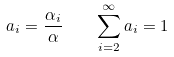Convert formula to latex. <formula><loc_0><loc_0><loc_500><loc_500>a _ { i } = \frac { \alpha _ { i } } { \alpha } \quad \sum _ { i = 2 } ^ { \infty } a _ { i } = 1</formula> 